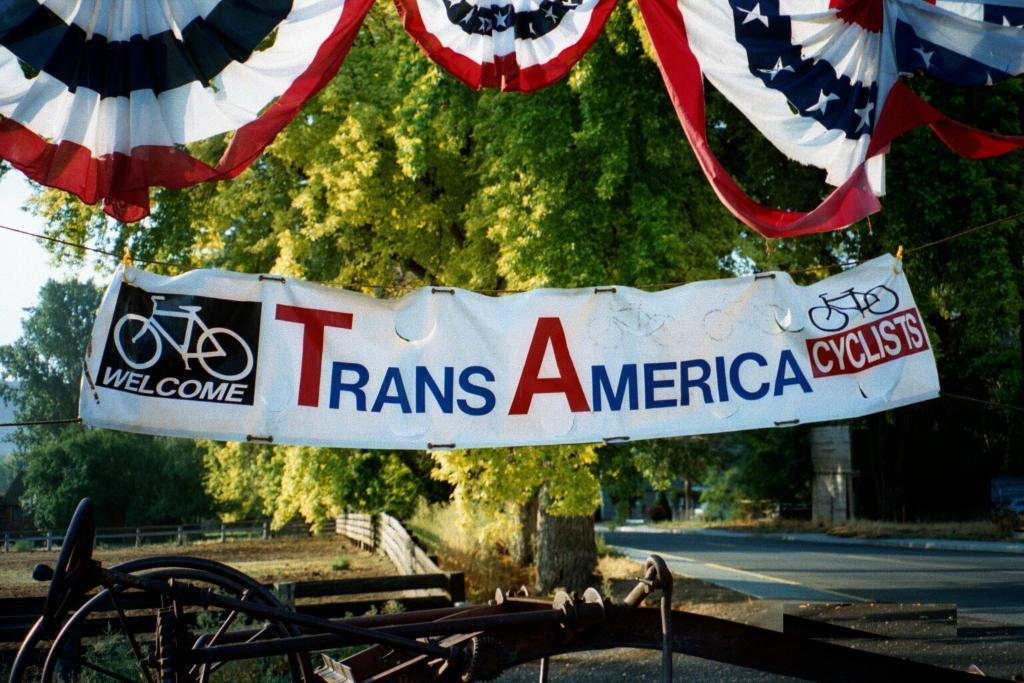What is present in the image that is used for displaying information or messages? There is a banner in the image. What object can be seen in the image that has a circular shape? There is a wheel in the image. What type of natural scenery is visible in the background of the image? There are trees in the background of the image. What architectural feature can be seen in the background of the image? There is a fence in the background of the image. How many sisters are sitting at the breakfast table in the image? There is no mention of sisters or a breakfast table in the image. What type of drawer can be seen in the image? There is no drawer present in the image. 